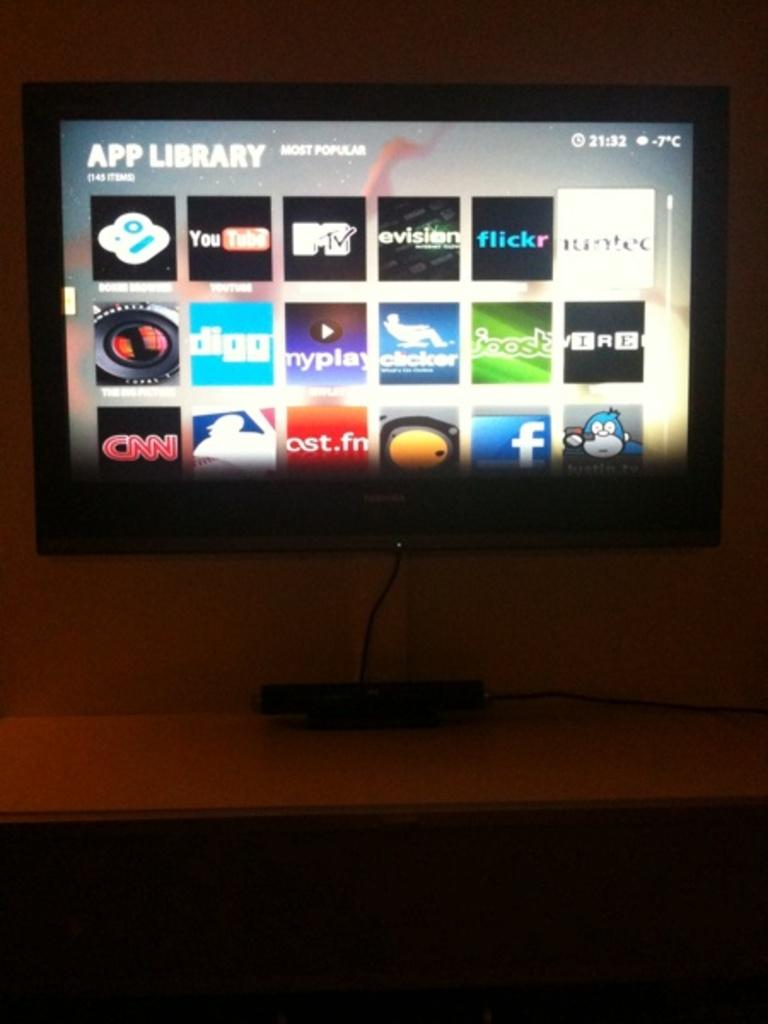<image>
Share a concise interpretation of the image provided. A television mounted to the wall has several different apps showing under the heading app library. 